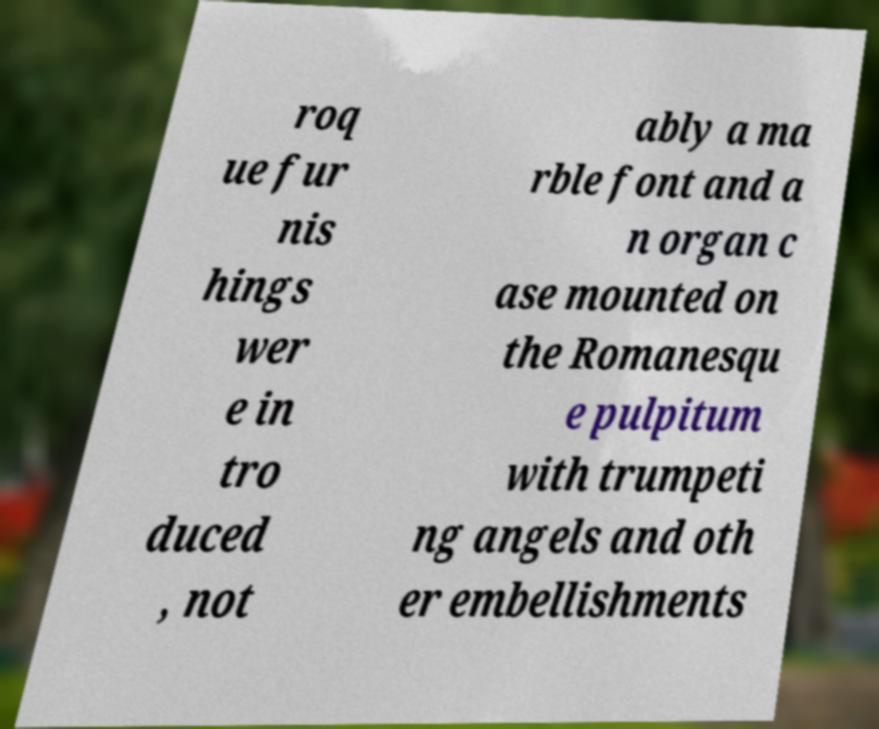Could you extract and type out the text from this image? roq ue fur nis hings wer e in tro duced , not ably a ma rble font and a n organ c ase mounted on the Romanesqu e pulpitum with trumpeti ng angels and oth er embellishments 